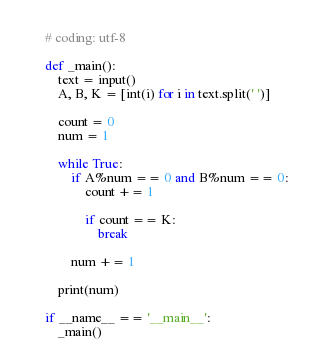<code> <loc_0><loc_0><loc_500><loc_500><_Python_># coding: utf-8

def _main():
    text = input()
    A, B, K = [int(i) for i in text.split(' ')]

    count = 0
    num = 1

    while True:
        if A%num == 0 and B%num == 0:
            count += 1

            if count == K:
                break

        num += 1

    print(num)

if __name__ == '__main__':
    _main()</code> 